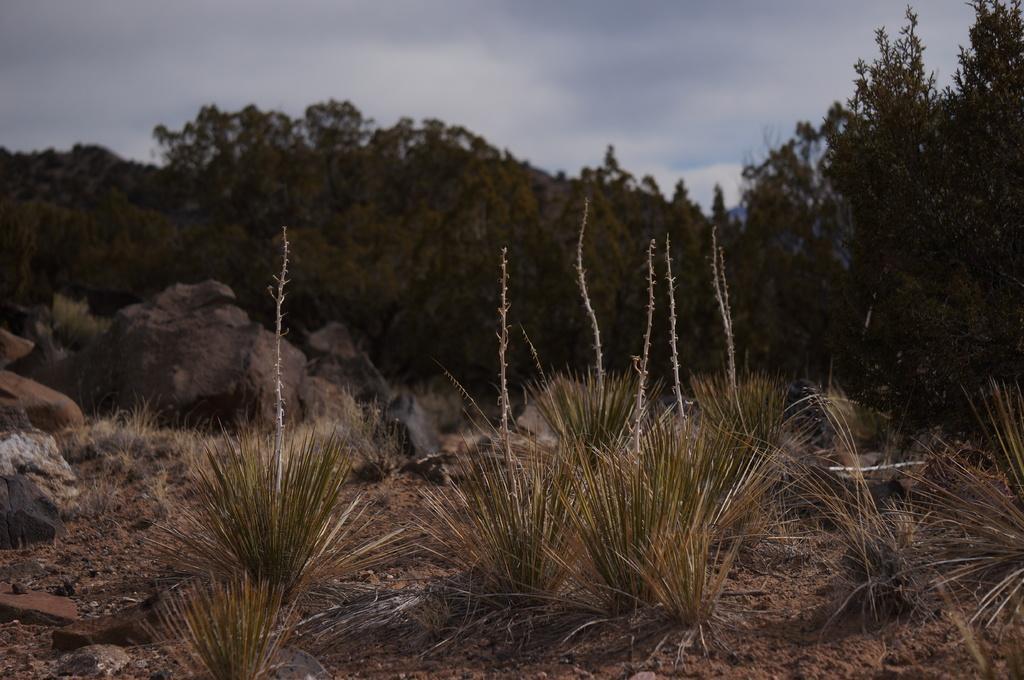Could you give a brief overview of what you see in this image? In this image I can see the ground, some grass on the ground, few rocks and few trees which are green in color. In the background I can see the sky. 